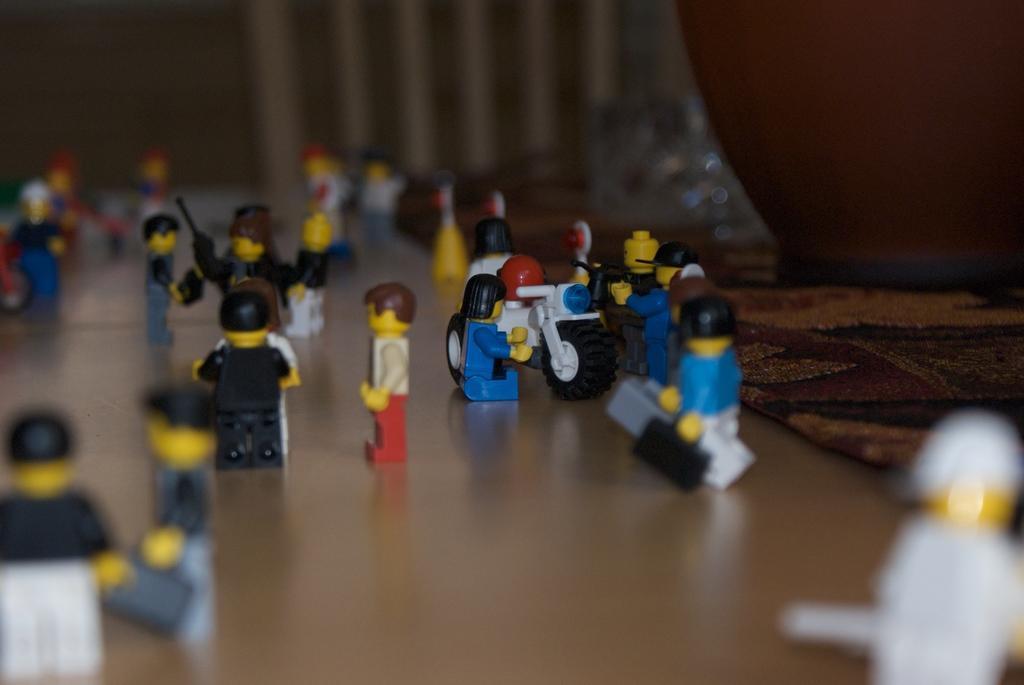Could you give a brief overview of what you see in this image? In this image there are so many Lego toys on the wooden board , and in the background there is a cloth. 